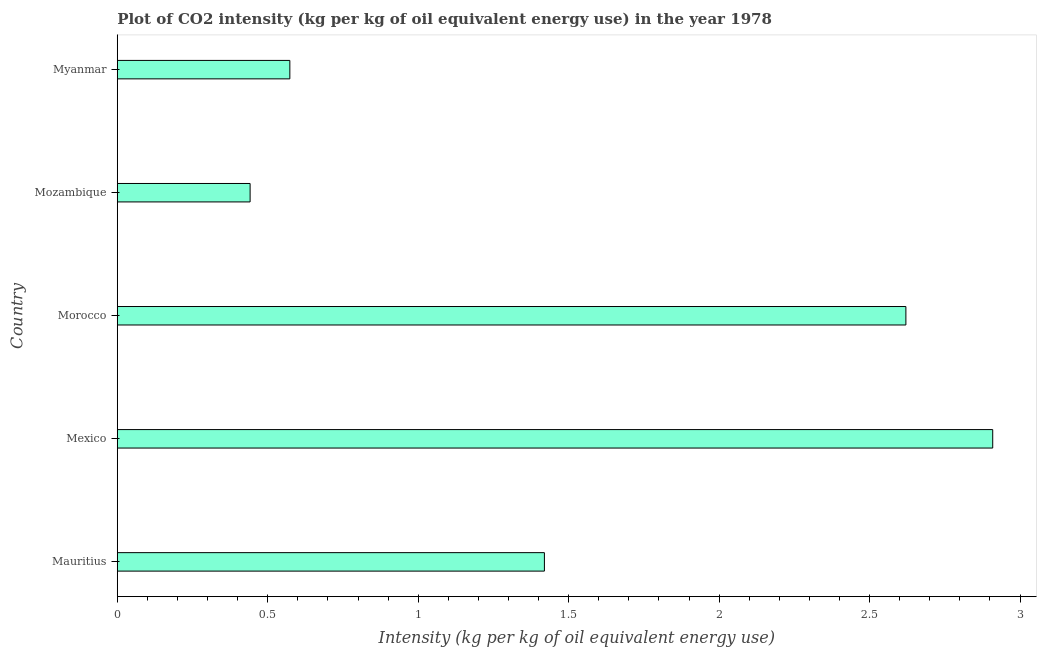Does the graph contain grids?
Your answer should be compact. No. What is the title of the graph?
Your answer should be compact. Plot of CO2 intensity (kg per kg of oil equivalent energy use) in the year 1978. What is the label or title of the X-axis?
Give a very brief answer. Intensity (kg per kg of oil equivalent energy use). What is the label or title of the Y-axis?
Keep it short and to the point. Country. What is the co2 intensity in Morocco?
Keep it short and to the point. 2.62. Across all countries, what is the maximum co2 intensity?
Your response must be concise. 2.91. Across all countries, what is the minimum co2 intensity?
Provide a short and direct response. 0.44. In which country was the co2 intensity maximum?
Keep it short and to the point. Mexico. In which country was the co2 intensity minimum?
Give a very brief answer. Mozambique. What is the sum of the co2 intensity?
Offer a terse response. 7.96. What is the difference between the co2 intensity in Mexico and Myanmar?
Make the answer very short. 2.34. What is the average co2 intensity per country?
Your answer should be very brief. 1.59. What is the median co2 intensity?
Your answer should be compact. 1.42. In how many countries, is the co2 intensity greater than 2.3 kg?
Your response must be concise. 2. What is the ratio of the co2 intensity in Mauritius to that in Mexico?
Keep it short and to the point. 0.49. Is the difference between the co2 intensity in Morocco and Mozambique greater than the difference between any two countries?
Ensure brevity in your answer.  No. What is the difference between the highest and the second highest co2 intensity?
Give a very brief answer. 0.29. What is the difference between the highest and the lowest co2 intensity?
Ensure brevity in your answer.  2.47. How many bars are there?
Keep it short and to the point. 5. Are all the bars in the graph horizontal?
Your answer should be very brief. Yes. What is the difference between two consecutive major ticks on the X-axis?
Ensure brevity in your answer.  0.5. What is the Intensity (kg per kg of oil equivalent energy use) in Mauritius?
Provide a short and direct response. 1.42. What is the Intensity (kg per kg of oil equivalent energy use) in Mexico?
Give a very brief answer. 2.91. What is the Intensity (kg per kg of oil equivalent energy use) in Morocco?
Keep it short and to the point. 2.62. What is the Intensity (kg per kg of oil equivalent energy use) in Mozambique?
Offer a terse response. 0.44. What is the Intensity (kg per kg of oil equivalent energy use) in Myanmar?
Your response must be concise. 0.57. What is the difference between the Intensity (kg per kg of oil equivalent energy use) in Mauritius and Mexico?
Your answer should be very brief. -1.49. What is the difference between the Intensity (kg per kg of oil equivalent energy use) in Mauritius and Morocco?
Your answer should be compact. -1.2. What is the difference between the Intensity (kg per kg of oil equivalent energy use) in Mauritius and Mozambique?
Offer a terse response. 0.98. What is the difference between the Intensity (kg per kg of oil equivalent energy use) in Mauritius and Myanmar?
Make the answer very short. 0.85. What is the difference between the Intensity (kg per kg of oil equivalent energy use) in Mexico and Morocco?
Your answer should be very brief. 0.29. What is the difference between the Intensity (kg per kg of oil equivalent energy use) in Mexico and Mozambique?
Provide a short and direct response. 2.47. What is the difference between the Intensity (kg per kg of oil equivalent energy use) in Mexico and Myanmar?
Offer a terse response. 2.34. What is the difference between the Intensity (kg per kg of oil equivalent energy use) in Morocco and Mozambique?
Provide a succinct answer. 2.18. What is the difference between the Intensity (kg per kg of oil equivalent energy use) in Morocco and Myanmar?
Offer a terse response. 2.05. What is the difference between the Intensity (kg per kg of oil equivalent energy use) in Mozambique and Myanmar?
Provide a succinct answer. -0.13. What is the ratio of the Intensity (kg per kg of oil equivalent energy use) in Mauritius to that in Mexico?
Offer a terse response. 0.49. What is the ratio of the Intensity (kg per kg of oil equivalent energy use) in Mauritius to that in Morocco?
Offer a very short reply. 0.54. What is the ratio of the Intensity (kg per kg of oil equivalent energy use) in Mauritius to that in Mozambique?
Your answer should be very brief. 3.22. What is the ratio of the Intensity (kg per kg of oil equivalent energy use) in Mauritius to that in Myanmar?
Offer a very short reply. 2.48. What is the ratio of the Intensity (kg per kg of oil equivalent energy use) in Mexico to that in Morocco?
Give a very brief answer. 1.11. What is the ratio of the Intensity (kg per kg of oil equivalent energy use) in Mexico to that in Mozambique?
Keep it short and to the point. 6.59. What is the ratio of the Intensity (kg per kg of oil equivalent energy use) in Mexico to that in Myanmar?
Offer a very short reply. 5.07. What is the ratio of the Intensity (kg per kg of oil equivalent energy use) in Morocco to that in Mozambique?
Your answer should be very brief. 5.94. What is the ratio of the Intensity (kg per kg of oil equivalent energy use) in Morocco to that in Myanmar?
Offer a terse response. 4.57. What is the ratio of the Intensity (kg per kg of oil equivalent energy use) in Mozambique to that in Myanmar?
Give a very brief answer. 0.77. 